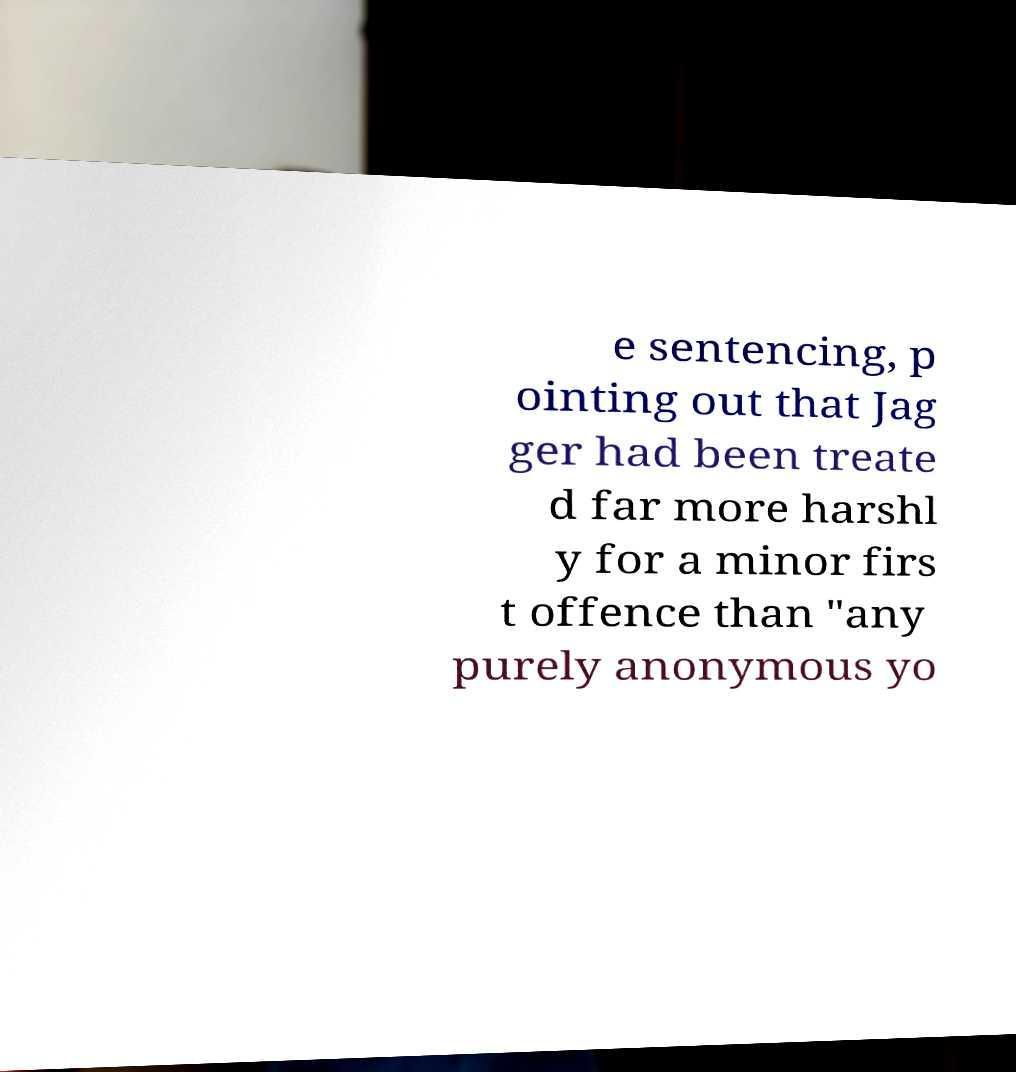Please read and relay the text visible in this image. What does it say? e sentencing, p ointing out that Jag ger had been treate d far more harshl y for a minor firs t offence than "any purely anonymous yo 